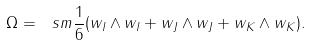Convert formula to latex. <formula><loc_0><loc_0><loc_500><loc_500>\Omega = \ s m { \frac { 1 } { 6 } } ( w _ { I } \wedge w _ { I } + w _ { J } \wedge w _ { J } + w _ { K } \wedge w _ { K } ) .</formula> 